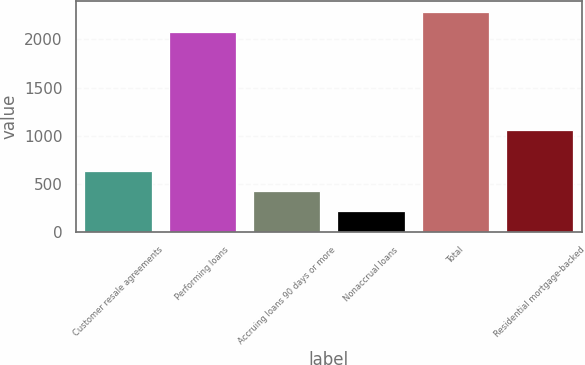Convert chart. <chart><loc_0><loc_0><loc_500><loc_500><bar_chart><fcel>Customer resale agreements<fcel>Performing loans<fcel>Accruing loans 90 days or more<fcel>Nonaccrual loans<fcel>Total<fcel>Residential mortgage-backed<nl><fcel>634.4<fcel>2072<fcel>425.6<fcel>216.8<fcel>2280.8<fcel>1058<nl></chart> 